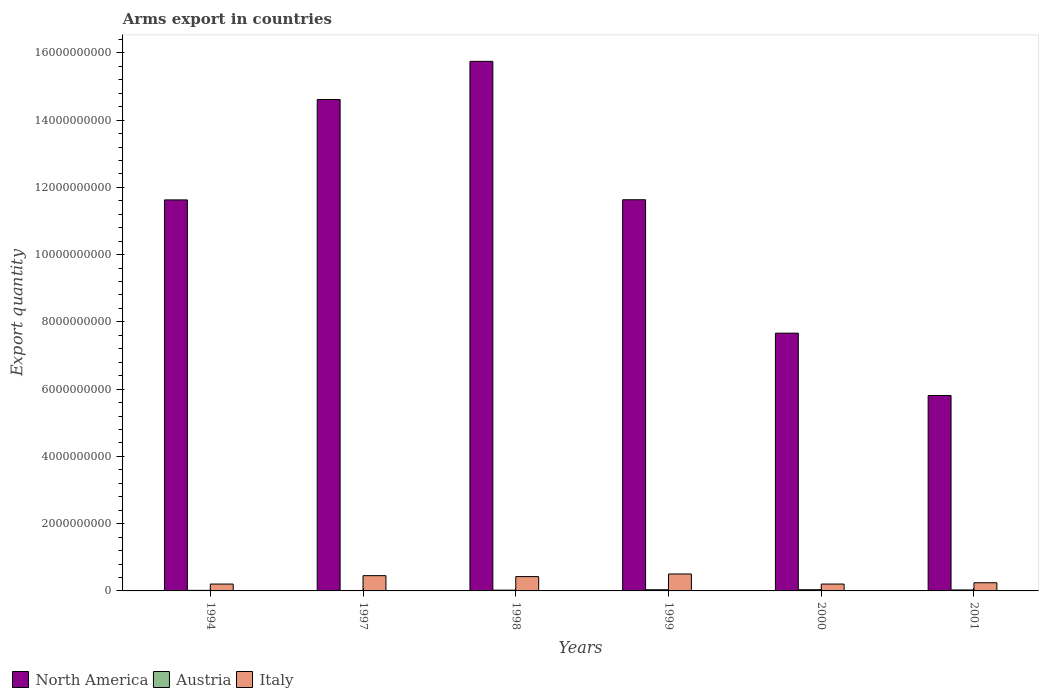Are the number of bars per tick equal to the number of legend labels?
Offer a terse response. Yes. Are the number of bars on each tick of the X-axis equal?
Ensure brevity in your answer.  Yes. How many bars are there on the 2nd tick from the left?
Your answer should be very brief. 3. How many bars are there on the 6th tick from the right?
Keep it short and to the point. 3. In how many cases, is the number of bars for a given year not equal to the number of legend labels?
Provide a succinct answer. 0. What is the total arms export in Austria in 1998?
Make the answer very short. 2.30e+07. Across all years, what is the maximum total arms export in Italy?
Your answer should be very brief. 5.04e+08. Across all years, what is the minimum total arms export in Italy?
Your answer should be very brief. 2.04e+08. In which year was the total arms export in North America maximum?
Provide a short and direct response. 1998. What is the total total arms export in Italy in the graph?
Your answer should be compact. 2.04e+09. What is the difference between the total arms export in North America in 2000 and that in 2001?
Make the answer very short. 1.85e+09. What is the difference between the total arms export in Italy in 1997 and the total arms export in Austria in 1999?
Offer a terse response. 4.19e+08. What is the average total arms export in Austria per year?
Provide a short and direct response. 2.55e+07. In the year 1994, what is the difference between the total arms export in Italy and total arms export in Austria?
Your answer should be very brief. 1.87e+08. In how many years, is the total arms export in Austria greater than 4000000000?
Your answer should be compact. 0. What is the ratio of the total arms export in Austria in 1999 to that in 2000?
Your answer should be very brief. 0.97. Is the total arms export in North America in 1999 less than that in 2000?
Your response must be concise. No. Is the difference between the total arms export in Italy in 1998 and 2000 greater than the difference between the total arms export in Austria in 1998 and 2000?
Make the answer very short. Yes. What is the difference between the highest and the second highest total arms export in Italy?
Give a very brief answer. 5.00e+07. What is the difference between the highest and the lowest total arms export in North America?
Ensure brevity in your answer.  9.94e+09. What does the 3rd bar from the left in 2000 represents?
Your answer should be compact. Italy. How many bars are there?
Provide a short and direct response. 18. How many years are there in the graph?
Provide a succinct answer. 6. Does the graph contain grids?
Keep it short and to the point. No. Where does the legend appear in the graph?
Your answer should be compact. Bottom left. How many legend labels are there?
Your answer should be very brief. 3. What is the title of the graph?
Give a very brief answer. Arms export in countries. Does "Belize" appear as one of the legend labels in the graph?
Your response must be concise. No. What is the label or title of the Y-axis?
Provide a short and direct response. Export quantity. What is the Export quantity of North America in 1994?
Offer a terse response. 1.16e+1. What is the Export quantity of Austria in 1994?
Provide a succinct answer. 1.70e+07. What is the Export quantity in Italy in 1994?
Your answer should be very brief. 2.04e+08. What is the Export quantity of North America in 1997?
Provide a succinct answer. 1.46e+1. What is the Export quantity in Austria in 1997?
Offer a terse response. 1.30e+07. What is the Export quantity in Italy in 1997?
Give a very brief answer. 4.54e+08. What is the Export quantity in North America in 1998?
Your answer should be very brief. 1.57e+1. What is the Export quantity of Austria in 1998?
Give a very brief answer. 2.30e+07. What is the Export quantity in Italy in 1998?
Provide a succinct answer. 4.26e+08. What is the Export quantity of North America in 1999?
Offer a terse response. 1.16e+1. What is the Export quantity in Austria in 1999?
Make the answer very short. 3.50e+07. What is the Export quantity in Italy in 1999?
Ensure brevity in your answer.  5.04e+08. What is the Export quantity of North America in 2000?
Your answer should be very brief. 7.66e+09. What is the Export quantity of Austria in 2000?
Give a very brief answer. 3.60e+07. What is the Export quantity of Italy in 2000?
Offer a very short reply. 2.04e+08. What is the Export quantity of North America in 2001?
Your answer should be very brief. 5.81e+09. What is the Export quantity of Austria in 2001?
Your answer should be very brief. 2.90e+07. What is the Export quantity of Italy in 2001?
Give a very brief answer. 2.43e+08. Across all years, what is the maximum Export quantity in North America?
Keep it short and to the point. 1.57e+1. Across all years, what is the maximum Export quantity of Austria?
Ensure brevity in your answer.  3.60e+07. Across all years, what is the maximum Export quantity in Italy?
Make the answer very short. 5.04e+08. Across all years, what is the minimum Export quantity of North America?
Offer a terse response. 5.81e+09. Across all years, what is the minimum Export quantity in Austria?
Provide a succinct answer. 1.30e+07. Across all years, what is the minimum Export quantity in Italy?
Make the answer very short. 2.04e+08. What is the total Export quantity in North America in the graph?
Offer a terse response. 6.71e+1. What is the total Export quantity in Austria in the graph?
Keep it short and to the point. 1.53e+08. What is the total Export quantity of Italy in the graph?
Your answer should be very brief. 2.04e+09. What is the difference between the Export quantity in North America in 1994 and that in 1997?
Offer a very short reply. -2.98e+09. What is the difference between the Export quantity of Italy in 1994 and that in 1997?
Give a very brief answer. -2.50e+08. What is the difference between the Export quantity of North America in 1994 and that in 1998?
Your answer should be very brief. -4.12e+09. What is the difference between the Export quantity in Austria in 1994 and that in 1998?
Your answer should be compact. -6.00e+06. What is the difference between the Export quantity of Italy in 1994 and that in 1998?
Offer a terse response. -2.22e+08. What is the difference between the Export quantity of North America in 1994 and that in 1999?
Your answer should be very brief. -4.00e+06. What is the difference between the Export quantity in Austria in 1994 and that in 1999?
Your response must be concise. -1.80e+07. What is the difference between the Export quantity in Italy in 1994 and that in 1999?
Make the answer very short. -3.00e+08. What is the difference between the Export quantity of North America in 1994 and that in 2000?
Provide a succinct answer. 3.96e+09. What is the difference between the Export quantity of Austria in 1994 and that in 2000?
Provide a succinct answer. -1.90e+07. What is the difference between the Export quantity of North America in 1994 and that in 2001?
Ensure brevity in your answer.  5.82e+09. What is the difference between the Export quantity of Austria in 1994 and that in 2001?
Offer a terse response. -1.20e+07. What is the difference between the Export quantity in Italy in 1994 and that in 2001?
Your response must be concise. -3.90e+07. What is the difference between the Export quantity of North America in 1997 and that in 1998?
Offer a very short reply. -1.14e+09. What is the difference between the Export quantity in Austria in 1997 and that in 1998?
Provide a short and direct response. -1.00e+07. What is the difference between the Export quantity of Italy in 1997 and that in 1998?
Your answer should be very brief. 2.80e+07. What is the difference between the Export quantity in North America in 1997 and that in 1999?
Offer a very short reply. 2.98e+09. What is the difference between the Export quantity of Austria in 1997 and that in 1999?
Provide a short and direct response. -2.20e+07. What is the difference between the Export quantity of Italy in 1997 and that in 1999?
Offer a very short reply. -5.00e+07. What is the difference between the Export quantity of North America in 1997 and that in 2000?
Give a very brief answer. 6.95e+09. What is the difference between the Export quantity of Austria in 1997 and that in 2000?
Offer a very short reply. -2.30e+07. What is the difference between the Export quantity in Italy in 1997 and that in 2000?
Your answer should be very brief. 2.50e+08. What is the difference between the Export quantity in North America in 1997 and that in 2001?
Give a very brief answer. 8.80e+09. What is the difference between the Export quantity of Austria in 1997 and that in 2001?
Provide a short and direct response. -1.60e+07. What is the difference between the Export quantity in Italy in 1997 and that in 2001?
Offer a terse response. 2.11e+08. What is the difference between the Export quantity of North America in 1998 and that in 1999?
Make the answer very short. 4.12e+09. What is the difference between the Export quantity of Austria in 1998 and that in 1999?
Provide a short and direct response. -1.20e+07. What is the difference between the Export quantity of Italy in 1998 and that in 1999?
Ensure brevity in your answer.  -7.80e+07. What is the difference between the Export quantity of North America in 1998 and that in 2000?
Make the answer very short. 8.08e+09. What is the difference between the Export quantity of Austria in 1998 and that in 2000?
Offer a terse response. -1.30e+07. What is the difference between the Export quantity in Italy in 1998 and that in 2000?
Your response must be concise. 2.22e+08. What is the difference between the Export quantity of North America in 1998 and that in 2001?
Ensure brevity in your answer.  9.94e+09. What is the difference between the Export quantity in Austria in 1998 and that in 2001?
Offer a terse response. -6.00e+06. What is the difference between the Export quantity of Italy in 1998 and that in 2001?
Make the answer very short. 1.83e+08. What is the difference between the Export quantity in North America in 1999 and that in 2000?
Give a very brief answer. 3.97e+09. What is the difference between the Export quantity of Italy in 1999 and that in 2000?
Keep it short and to the point. 3.00e+08. What is the difference between the Export quantity of North America in 1999 and that in 2001?
Your answer should be compact. 5.82e+09. What is the difference between the Export quantity in Austria in 1999 and that in 2001?
Offer a very short reply. 6.00e+06. What is the difference between the Export quantity in Italy in 1999 and that in 2001?
Give a very brief answer. 2.61e+08. What is the difference between the Export quantity of North America in 2000 and that in 2001?
Provide a short and direct response. 1.85e+09. What is the difference between the Export quantity of Austria in 2000 and that in 2001?
Your answer should be compact. 7.00e+06. What is the difference between the Export quantity in Italy in 2000 and that in 2001?
Provide a short and direct response. -3.90e+07. What is the difference between the Export quantity of North America in 1994 and the Export quantity of Austria in 1997?
Offer a terse response. 1.16e+1. What is the difference between the Export quantity in North America in 1994 and the Export quantity in Italy in 1997?
Give a very brief answer. 1.12e+1. What is the difference between the Export quantity in Austria in 1994 and the Export quantity in Italy in 1997?
Provide a succinct answer. -4.37e+08. What is the difference between the Export quantity in North America in 1994 and the Export quantity in Austria in 1998?
Provide a succinct answer. 1.16e+1. What is the difference between the Export quantity in North America in 1994 and the Export quantity in Italy in 1998?
Ensure brevity in your answer.  1.12e+1. What is the difference between the Export quantity in Austria in 1994 and the Export quantity in Italy in 1998?
Provide a succinct answer. -4.09e+08. What is the difference between the Export quantity of North America in 1994 and the Export quantity of Austria in 1999?
Make the answer very short. 1.16e+1. What is the difference between the Export quantity of North America in 1994 and the Export quantity of Italy in 1999?
Ensure brevity in your answer.  1.11e+1. What is the difference between the Export quantity of Austria in 1994 and the Export quantity of Italy in 1999?
Provide a short and direct response. -4.87e+08. What is the difference between the Export quantity of North America in 1994 and the Export quantity of Austria in 2000?
Ensure brevity in your answer.  1.16e+1. What is the difference between the Export quantity in North America in 1994 and the Export quantity in Italy in 2000?
Keep it short and to the point. 1.14e+1. What is the difference between the Export quantity of Austria in 1994 and the Export quantity of Italy in 2000?
Give a very brief answer. -1.87e+08. What is the difference between the Export quantity of North America in 1994 and the Export quantity of Austria in 2001?
Provide a succinct answer. 1.16e+1. What is the difference between the Export quantity in North America in 1994 and the Export quantity in Italy in 2001?
Your response must be concise. 1.14e+1. What is the difference between the Export quantity of Austria in 1994 and the Export quantity of Italy in 2001?
Provide a succinct answer. -2.26e+08. What is the difference between the Export quantity in North America in 1997 and the Export quantity in Austria in 1998?
Your answer should be very brief. 1.46e+1. What is the difference between the Export quantity of North America in 1997 and the Export quantity of Italy in 1998?
Offer a terse response. 1.42e+1. What is the difference between the Export quantity in Austria in 1997 and the Export quantity in Italy in 1998?
Ensure brevity in your answer.  -4.13e+08. What is the difference between the Export quantity in North America in 1997 and the Export quantity in Austria in 1999?
Provide a short and direct response. 1.46e+1. What is the difference between the Export quantity in North America in 1997 and the Export quantity in Italy in 1999?
Offer a very short reply. 1.41e+1. What is the difference between the Export quantity in Austria in 1997 and the Export quantity in Italy in 1999?
Give a very brief answer. -4.91e+08. What is the difference between the Export quantity in North America in 1997 and the Export quantity in Austria in 2000?
Your response must be concise. 1.46e+1. What is the difference between the Export quantity of North America in 1997 and the Export quantity of Italy in 2000?
Make the answer very short. 1.44e+1. What is the difference between the Export quantity in Austria in 1997 and the Export quantity in Italy in 2000?
Your answer should be compact. -1.91e+08. What is the difference between the Export quantity in North America in 1997 and the Export quantity in Austria in 2001?
Offer a very short reply. 1.46e+1. What is the difference between the Export quantity in North America in 1997 and the Export quantity in Italy in 2001?
Keep it short and to the point. 1.44e+1. What is the difference between the Export quantity of Austria in 1997 and the Export quantity of Italy in 2001?
Offer a terse response. -2.30e+08. What is the difference between the Export quantity of North America in 1998 and the Export quantity of Austria in 1999?
Provide a short and direct response. 1.57e+1. What is the difference between the Export quantity of North America in 1998 and the Export quantity of Italy in 1999?
Make the answer very short. 1.52e+1. What is the difference between the Export quantity of Austria in 1998 and the Export quantity of Italy in 1999?
Keep it short and to the point. -4.81e+08. What is the difference between the Export quantity in North America in 1998 and the Export quantity in Austria in 2000?
Make the answer very short. 1.57e+1. What is the difference between the Export quantity in North America in 1998 and the Export quantity in Italy in 2000?
Provide a short and direct response. 1.55e+1. What is the difference between the Export quantity in Austria in 1998 and the Export quantity in Italy in 2000?
Make the answer very short. -1.81e+08. What is the difference between the Export quantity in North America in 1998 and the Export quantity in Austria in 2001?
Offer a terse response. 1.57e+1. What is the difference between the Export quantity of North America in 1998 and the Export quantity of Italy in 2001?
Provide a succinct answer. 1.55e+1. What is the difference between the Export quantity of Austria in 1998 and the Export quantity of Italy in 2001?
Your answer should be compact. -2.20e+08. What is the difference between the Export quantity of North America in 1999 and the Export quantity of Austria in 2000?
Make the answer very short. 1.16e+1. What is the difference between the Export quantity in North America in 1999 and the Export quantity in Italy in 2000?
Provide a short and direct response. 1.14e+1. What is the difference between the Export quantity of Austria in 1999 and the Export quantity of Italy in 2000?
Provide a short and direct response. -1.69e+08. What is the difference between the Export quantity in North America in 1999 and the Export quantity in Austria in 2001?
Provide a succinct answer. 1.16e+1. What is the difference between the Export quantity of North America in 1999 and the Export quantity of Italy in 2001?
Provide a succinct answer. 1.14e+1. What is the difference between the Export quantity in Austria in 1999 and the Export quantity in Italy in 2001?
Offer a terse response. -2.08e+08. What is the difference between the Export quantity in North America in 2000 and the Export quantity in Austria in 2001?
Your answer should be very brief. 7.64e+09. What is the difference between the Export quantity in North America in 2000 and the Export quantity in Italy in 2001?
Provide a short and direct response. 7.42e+09. What is the difference between the Export quantity in Austria in 2000 and the Export quantity in Italy in 2001?
Provide a succinct answer. -2.07e+08. What is the average Export quantity of North America per year?
Keep it short and to the point. 1.12e+1. What is the average Export quantity of Austria per year?
Your response must be concise. 2.55e+07. What is the average Export quantity in Italy per year?
Offer a terse response. 3.39e+08. In the year 1994, what is the difference between the Export quantity in North America and Export quantity in Austria?
Provide a short and direct response. 1.16e+1. In the year 1994, what is the difference between the Export quantity of North America and Export quantity of Italy?
Your answer should be compact. 1.14e+1. In the year 1994, what is the difference between the Export quantity of Austria and Export quantity of Italy?
Keep it short and to the point. -1.87e+08. In the year 1997, what is the difference between the Export quantity in North America and Export quantity in Austria?
Your answer should be compact. 1.46e+1. In the year 1997, what is the difference between the Export quantity of North America and Export quantity of Italy?
Give a very brief answer. 1.42e+1. In the year 1997, what is the difference between the Export quantity of Austria and Export quantity of Italy?
Give a very brief answer. -4.41e+08. In the year 1998, what is the difference between the Export quantity in North America and Export quantity in Austria?
Ensure brevity in your answer.  1.57e+1. In the year 1998, what is the difference between the Export quantity in North America and Export quantity in Italy?
Your response must be concise. 1.53e+1. In the year 1998, what is the difference between the Export quantity of Austria and Export quantity of Italy?
Give a very brief answer. -4.03e+08. In the year 1999, what is the difference between the Export quantity of North America and Export quantity of Austria?
Offer a very short reply. 1.16e+1. In the year 1999, what is the difference between the Export quantity of North America and Export quantity of Italy?
Your response must be concise. 1.11e+1. In the year 1999, what is the difference between the Export quantity in Austria and Export quantity in Italy?
Keep it short and to the point. -4.69e+08. In the year 2000, what is the difference between the Export quantity of North America and Export quantity of Austria?
Ensure brevity in your answer.  7.63e+09. In the year 2000, what is the difference between the Export quantity of North America and Export quantity of Italy?
Offer a very short reply. 7.46e+09. In the year 2000, what is the difference between the Export quantity in Austria and Export quantity in Italy?
Keep it short and to the point. -1.68e+08. In the year 2001, what is the difference between the Export quantity of North America and Export quantity of Austria?
Offer a very short reply. 5.78e+09. In the year 2001, what is the difference between the Export quantity in North America and Export quantity in Italy?
Provide a short and direct response. 5.57e+09. In the year 2001, what is the difference between the Export quantity of Austria and Export quantity of Italy?
Offer a terse response. -2.14e+08. What is the ratio of the Export quantity in North America in 1994 to that in 1997?
Give a very brief answer. 0.8. What is the ratio of the Export quantity of Austria in 1994 to that in 1997?
Make the answer very short. 1.31. What is the ratio of the Export quantity of Italy in 1994 to that in 1997?
Make the answer very short. 0.45. What is the ratio of the Export quantity of North America in 1994 to that in 1998?
Offer a very short reply. 0.74. What is the ratio of the Export quantity of Austria in 1994 to that in 1998?
Offer a terse response. 0.74. What is the ratio of the Export quantity of Italy in 1994 to that in 1998?
Your response must be concise. 0.48. What is the ratio of the Export quantity of Austria in 1994 to that in 1999?
Offer a very short reply. 0.49. What is the ratio of the Export quantity in Italy in 1994 to that in 1999?
Provide a short and direct response. 0.4. What is the ratio of the Export quantity in North America in 1994 to that in 2000?
Give a very brief answer. 1.52. What is the ratio of the Export quantity in Austria in 1994 to that in 2000?
Make the answer very short. 0.47. What is the ratio of the Export quantity of Italy in 1994 to that in 2000?
Provide a short and direct response. 1. What is the ratio of the Export quantity of North America in 1994 to that in 2001?
Your answer should be very brief. 2. What is the ratio of the Export quantity of Austria in 1994 to that in 2001?
Ensure brevity in your answer.  0.59. What is the ratio of the Export quantity of Italy in 1994 to that in 2001?
Your answer should be compact. 0.84. What is the ratio of the Export quantity of North America in 1997 to that in 1998?
Offer a very short reply. 0.93. What is the ratio of the Export quantity of Austria in 1997 to that in 1998?
Provide a succinct answer. 0.57. What is the ratio of the Export quantity of Italy in 1997 to that in 1998?
Give a very brief answer. 1.07. What is the ratio of the Export quantity of North America in 1997 to that in 1999?
Your answer should be very brief. 1.26. What is the ratio of the Export quantity of Austria in 1997 to that in 1999?
Keep it short and to the point. 0.37. What is the ratio of the Export quantity in Italy in 1997 to that in 1999?
Ensure brevity in your answer.  0.9. What is the ratio of the Export quantity of North America in 1997 to that in 2000?
Your answer should be very brief. 1.91. What is the ratio of the Export quantity in Austria in 1997 to that in 2000?
Give a very brief answer. 0.36. What is the ratio of the Export quantity of Italy in 1997 to that in 2000?
Ensure brevity in your answer.  2.23. What is the ratio of the Export quantity of North America in 1997 to that in 2001?
Offer a very short reply. 2.51. What is the ratio of the Export quantity of Austria in 1997 to that in 2001?
Ensure brevity in your answer.  0.45. What is the ratio of the Export quantity in Italy in 1997 to that in 2001?
Make the answer very short. 1.87. What is the ratio of the Export quantity of North America in 1998 to that in 1999?
Your response must be concise. 1.35. What is the ratio of the Export quantity in Austria in 1998 to that in 1999?
Your answer should be very brief. 0.66. What is the ratio of the Export quantity of Italy in 1998 to that in 1999?
Provide a short and direct response. 0.85. What is the ratio of the Export quantity of North America in 1998 to that in 2000?
Keep it short and to the point. 2.05. What is the ratio of the Export quantity of Austria in 1998 to that in 2000?
Give a very brief answer. 0.64. What is the ratio of the Export quantity in Italy in 1998 to that in 2000?
Provide a succinct answer. 2.09. What is the ratio of the Export quantity of North America in 1998 to that in 2001?
Offer a very short reply. 2.71. What is the ratio of the Export quantity of Austria in 1998 to that in 2001?
Your answer should be compact. 0.79. What is the ratio of the Export quantity of Italy in 1998 to that in 2001?
Provide a short and direct response. 1.75. What is the ratio of the Export quantity in North America in 1999 to that in 2000?
Ensure brevity in your answer.  1.52. What is the ratio of the Export quantity in Austria in 1999 to that in 2000?
Keep it short and to the point. 0.97. What is the ratio of the Export quantity in Italy in 1999 to that in 2000?
Make the answer very short. 2.47. What is the ratio of the Export quantity of North America in 1999 to that in 2001?
Your response must be concise. 2. What is the ratio of the Export quantity in Austria in 1999 to that in 2001?
Offer a very short reply. 1.21. What is the ratio of the Export quantity in Italy in 1999 to that in 2001?
Offer a terse response. 2.07. What is the ratio of the Export quantity of North America in 2000 to that in 2001?
Your answer should be very brief. 1.32. What is the ratio of the Export quantity of Austria in 2000 to that in 2001?
Offer a terse response. 1.24. What is the ratio of the Export quantity in Italy in 2000 to that in 2001?
Your answer should be very brief. 0.84. What is the difference between the highest and the second highest Export quantity in North America?
Your answer should be very brief. 1.14e+09. What is the difference between the highest and the second highest Export quantity of Austria?
Offer a very short reply. 1.00e+06. What is the difference between the highest and the second highest Export quantity of Italy?
Your answer should be very brief. 5.00e+07. What is the difference between the highest and the lowest Export quantity of North America?
Your response must be concise. 9.94e+09. What is the difference between the highest and the lowest Export quantity in Austria?
Your response must be concise. 2.30e+07. What is the difference between the highest and the lowest Export quantity of Italy?
Make the answer very short. 3.00e+08. 